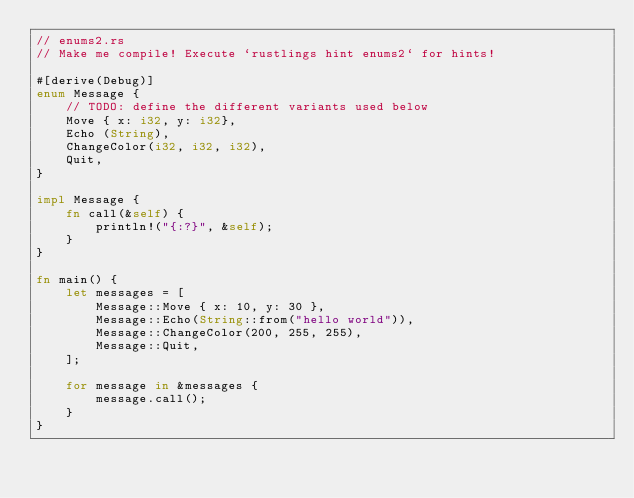<code> <loc_0><loc_0><loc_500><loc_500><_Rust_>// enums2.rs
// Make me compile! Execute `rustlings hint enums2` for hints!

#[derive(Debug)]
enum Message {
    // TODO: define the different variants used below
    Move { x: i32, y: i32},
    Echo (String),
    ChangeColor(i32, i32, i32),
    Quit,
}

impl Message {
    fn call(&self) {
        println!("{:?}", &self);
    }
}

fn main() {
    let messages = [
        Message::Move { x: 10, y: 30 },
        Message::Echo(String::from("hello world")),
        Message::ChangeColor(200, 255, 255),
        Message::Quit,
    ];

    for message in &messages {
        message.call();
    }
}
</code> 